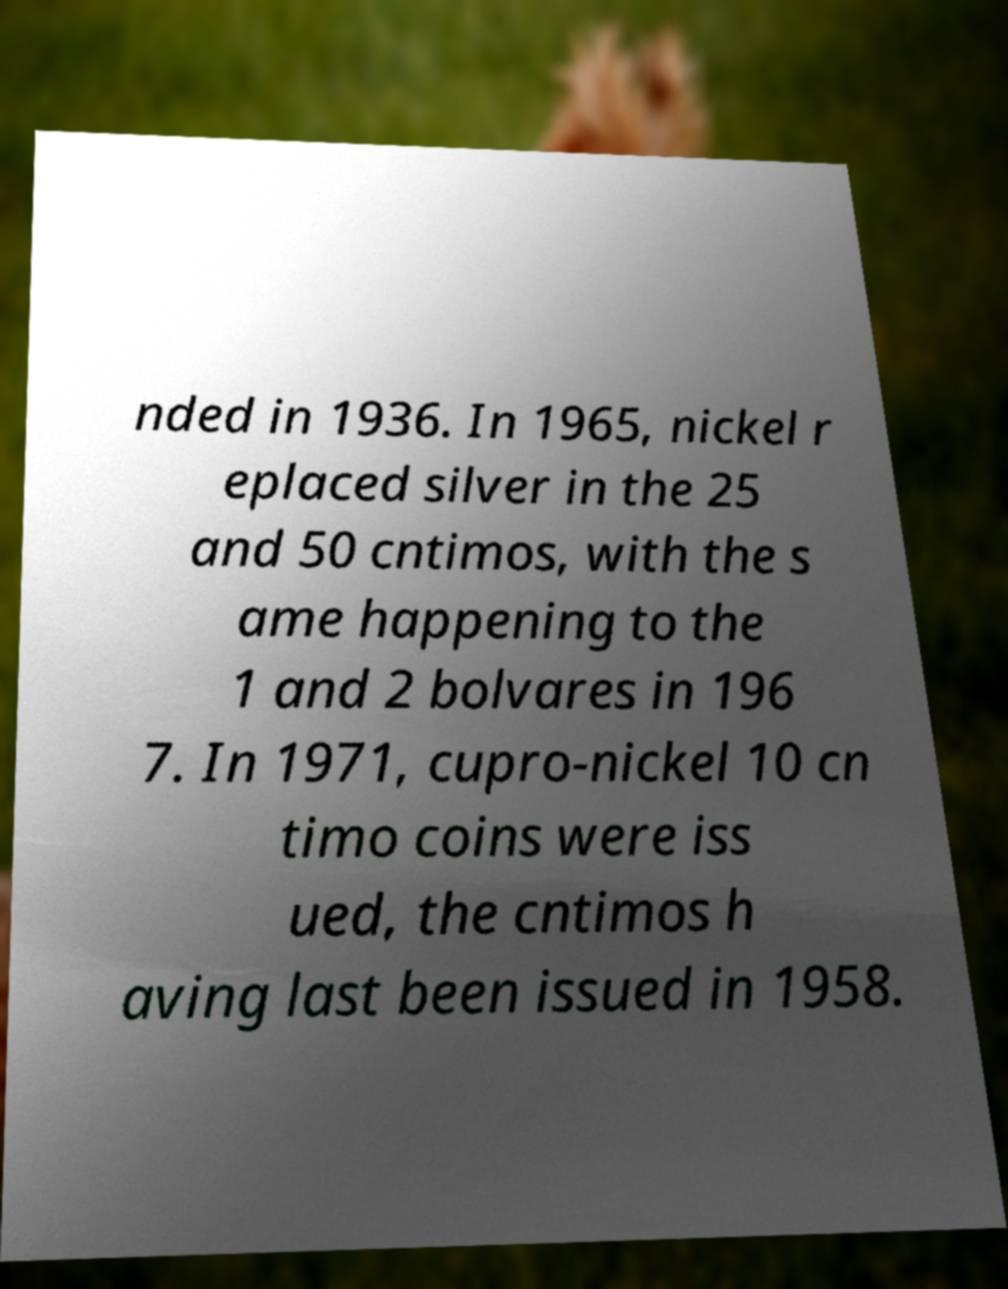Please identify and transcribe the text found in this image. nded in 1936. In 1965, nickel r eplaced silver in the 25 and 50 cntimos, with the s ame happening to the 1 and 2 bolvares in 196 7. In 1971, cupro-nickel 10 cn timo coins were iss ued, the cntimos h aving last been issued in 1958. 